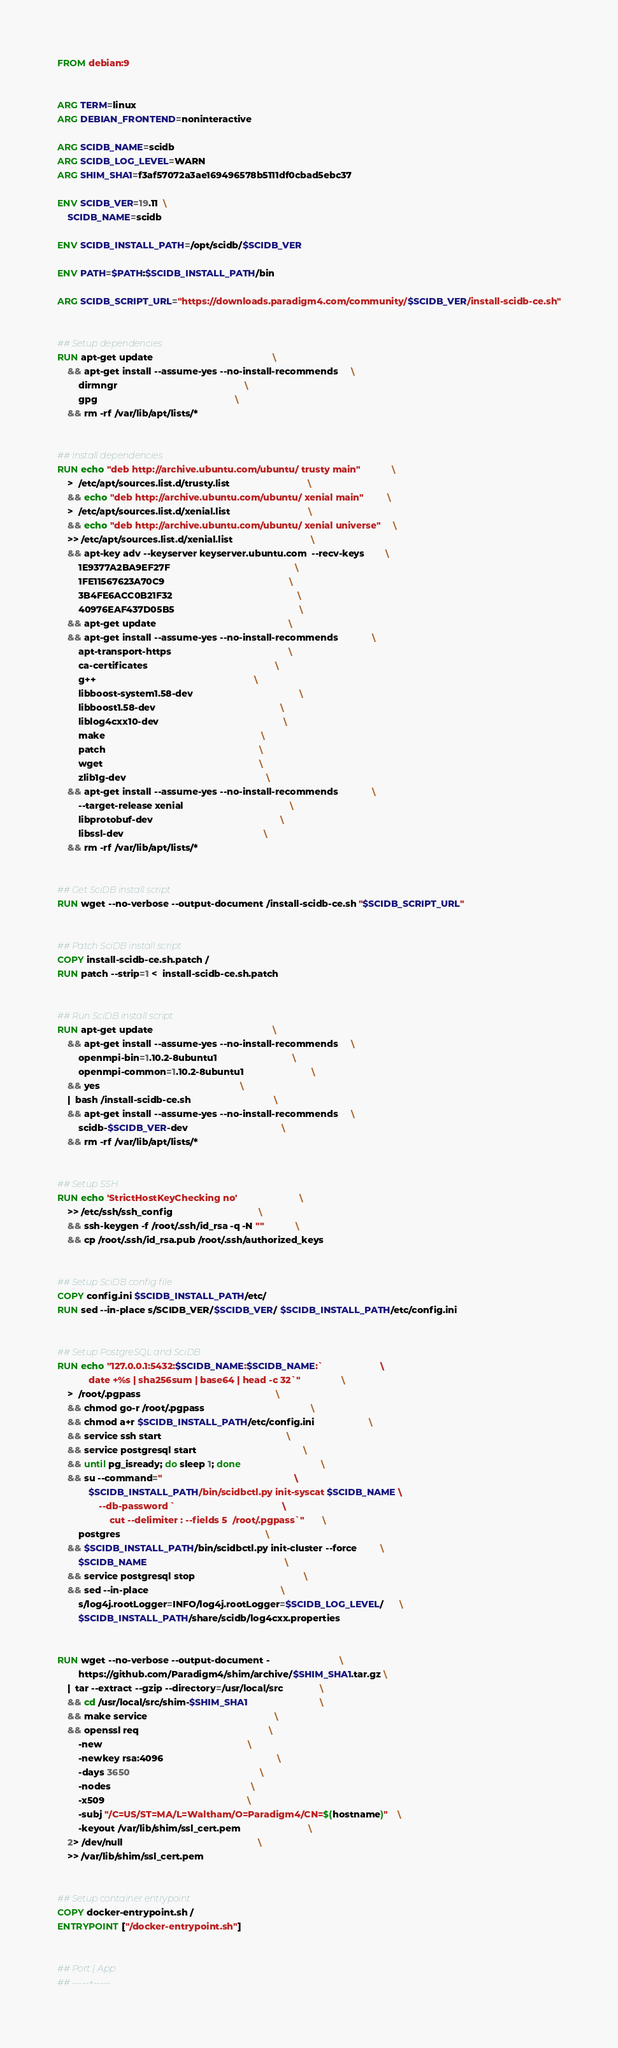Convert code to text. <code><loc_0><loc_0><loc_500><loc_500><_Dockerfile_>FROM debian:9


ARG TERM=linux
ARG DEBIAN_FRONTEND=noninteractive

ARG SCIDB_NAME=scidb
ARG SCIDB_LOG_LEVEL=WARN
ARG SHIM_SHA1=f3af57072a3ae169496578b5111df0cbad5ebc37

ENV SCIDB_VER=19.11  \
    SCIDB_NAME=scidb

ENV SCIDB_INSTALL_PATH=/opt/scidb/$SCIDB_VER

ENV PATH=$PATH:$SCIDB_INSTALL_PATH/bin

ARG SCIDB_SCRIPT_URL="https://downloads.paradigm4.com/community/$SCIDB_VER/install-scidb-ce.sh"


## Setup dependencies
RUN apt-get update                                              \
    && apt-get install --assume-yes --no-install-recommends     \
        dirmngr                                                 \
        gpg                                                     \
    && rm -rf /var/lib/apt/lists/*


## Install dependencies
RUN echo "deb http://archive.ubuntu.com/ubuntu/ trusty main"            \
    >  /etc/apt/sources.list.d/trusty.list                              \
    && echo "deb http://archive.ubuntu.com/ubuntu/ xenial main"         \
    >  /etc/apt/sources.list.d/xenial.list                              \
    && echo "deb http://archive.ubuntu.com/ubuntu/ xenial universe"     \
    >> /etc/apt/sources.list.d/xenial.list                              \
    && apt-key adv --keyserver keyserver.ubuntu.com  --recv-keys        \
        1E9377A2BA9EF27F                                                \
        1FE11567623A70C9                                                \
        3B4FE6ACC0B21F32                                                \
        40976EAF437D05B5                                                \
    && apt-get update                                                   \
    && apt-get install --assume-yes --no-install-recommends             \
        apt-transport-https                                             \
        ca-certificates                                                 \
        g++                                                             \
        libboost-system1.58-dev                                         \
        libboost1.58-dev                                                \
        liblog4cxx10-dev                                                \
        make                                                            \
        patch                                                           \
        wget                                                            \
        zlib1g-dev                                                      \
    && apt-get install --assume-yes --no-install-recommends             \
        --target-release xenial                                         \
        libprotobuf-dev                                                 \
        libssl-dev                                                      \
    && rm -rf /var/lib/apt/lists/*


## Get SciDB install script
RUN wget --no-verbose --output-document /install-scidb-ce.sh "$SCIDB_SCRIPT_URL"


## Patch SciDB install script
COPY install-scidb-ce.sh.patch /
RUN patch --strip=1 <  install-scidb-ce.sh.patch


## Run SciDB install script
RUN apt-get update                                              \
    && apt-get install --assume-yes --no-install-recommends     \
        openmpi-bin=1.10.2-8ubuntu1                             \
        openmpi-common=1.10.2-8ubuntu1                          \
    && yes                                                      \
    |  bash /install-scidb-ce.sh                                \
    && apt-get install --assume-yes --no-install-recommends     \
        scidb-$SCIDB_VER-dev                                    \
    && rm -rf /var/lib/apt/lists/*


## Setup SSH
RUN echo 'StrictHostKeyChecking no'                        \
    >> /etc/ssh/ssh_config                                 \
    && ssh-keygen -f /root/.ssh/id_rsa -q -N ""            \
    && cp /root/.ssh/id_rsa.pub /root/.ssh/authorized_keys


## Setup SciDB config file
COPY config.ini $SCIDB_INSTALL_PATH/etc/
RUN sed --in-place s/SCIDB_VER/$SCIDB_VER/ $SCIDB_INSTALL_PATH/etc/config.ini


## Setup PostgreSQL and SciDB
RUN echo "127.0.0.1:5432:$SCIDB_NAME:$SCIDB_NAME:`                      \
            date +%s | sha256sum | base64 | head -c 32`"                \
    >  /root/.pgpass                                                    \
    && chmod go-r /root/.pgpass                                         \
    && chmod a+r $SCIDB_INSTALL_PATH/etc/config.ini                     \
    && service ssh start                                                \
    && service postgresql start                                         \
    && until pg_isready; do sleep 1; done                               \
    && su --command="                                                   \
            $SCIDB_INSTALL_PATH/bin/scidbctl.py init-syscat $SCIDB_NAME \
                --db-password `                                         \
                    cut --delimiter : --fields 5  /root/.pgpass`"       \
        postgres                                                        \
    && $SCIDB_INSTALL_PATH/bin/scidbctl.py init-cluster --force         \
        $SCIDB_NAME                                                     \
    && service postgresql stop                                          \
    && sed --in-place                                                   \
        s/log4j.rootLogger=INFO/log4j.rootLogger=$SCIDB_LOG_LEVEL/      \
        $SCIDB_INSTALL_PATH/share/scidb/log4cxx.properties


RUN wget --no-verbose --output-document -                           \
        https://github.com/Paradigm4/shim/archive/$SHIM_SHA1.tar.gz \
    |  tar --extract --gzip --directory=/usr/local/src              \
    && cd /usr/local/src/shim-$SHIM_SHA1                            \
    && make service                                                 \
    && openssl req                                                  \
        -new                                                        \
        -newkey rsa:4096                                            \
        -days 3650                                                  \
        -nodes                                                      \
        -x509                                                       \
        -subj "/C=US/ST=MA/L=Waltham/O=Paradigm4/CN=$(hostname)"    \
        -keyout /var/lib/shim/ssl_cert.pem                          \
    2> /dev/null                                                    \
    >> /var/lib/shim/ssl_cert.pem


## Setup container entrypoint
COPY docker-entrypoint.sh /
ENTRYPOINT ["/docker-entrypoint.sh"]


## Port | App
## -----+-----</code> 